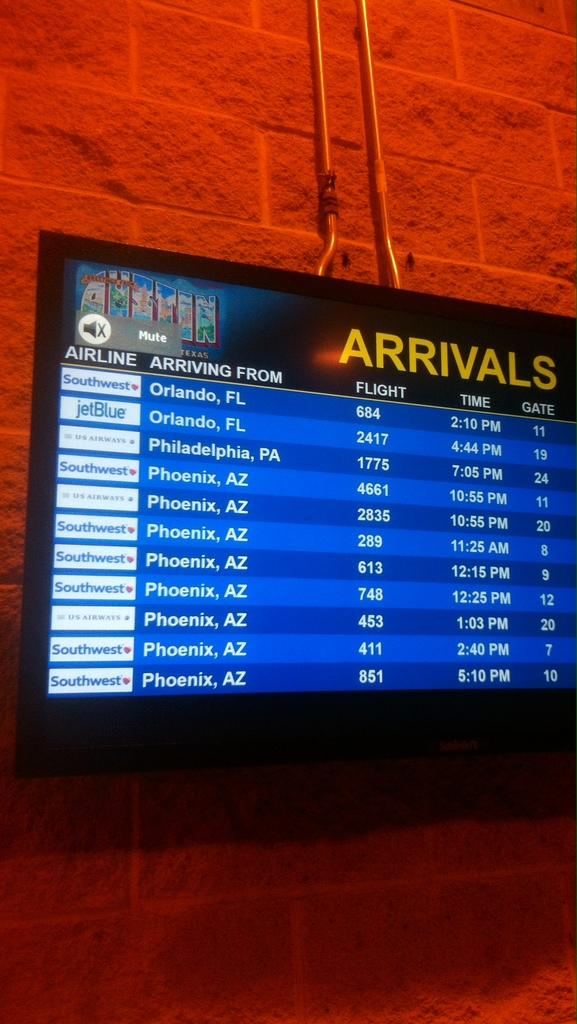<image>
Create a compact narrative representing the image presented. The panel indicate the flight 1775 from Philadelphia will be here at 7:05pm. 